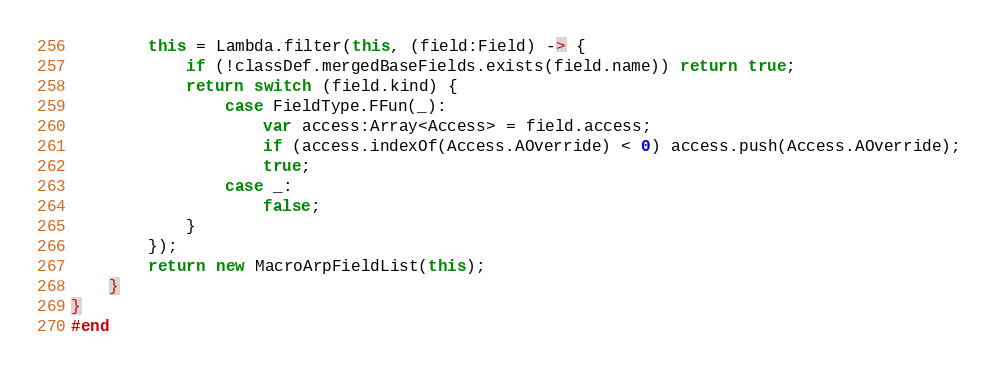Convert code to text. <code><loc_0><loc_0><loc_500><loc_500><_Haxe_>		this = Lambda.filter(this, (field:Field) -> {
			if (!classDef.mergedBaseFields.exists(field.name)) return true;
			return switch (field.kind) {
				case FieldType.FFun(_):
					var access:Array<Access> = field.access;
					if (access.indexOf(Access.AOverride) < 0) access.push(Access.AOverride);
					true;
				case _:
					false;
			}
		});
		return new MacroArpFieldList(this);
	}
}
#end
</code> 